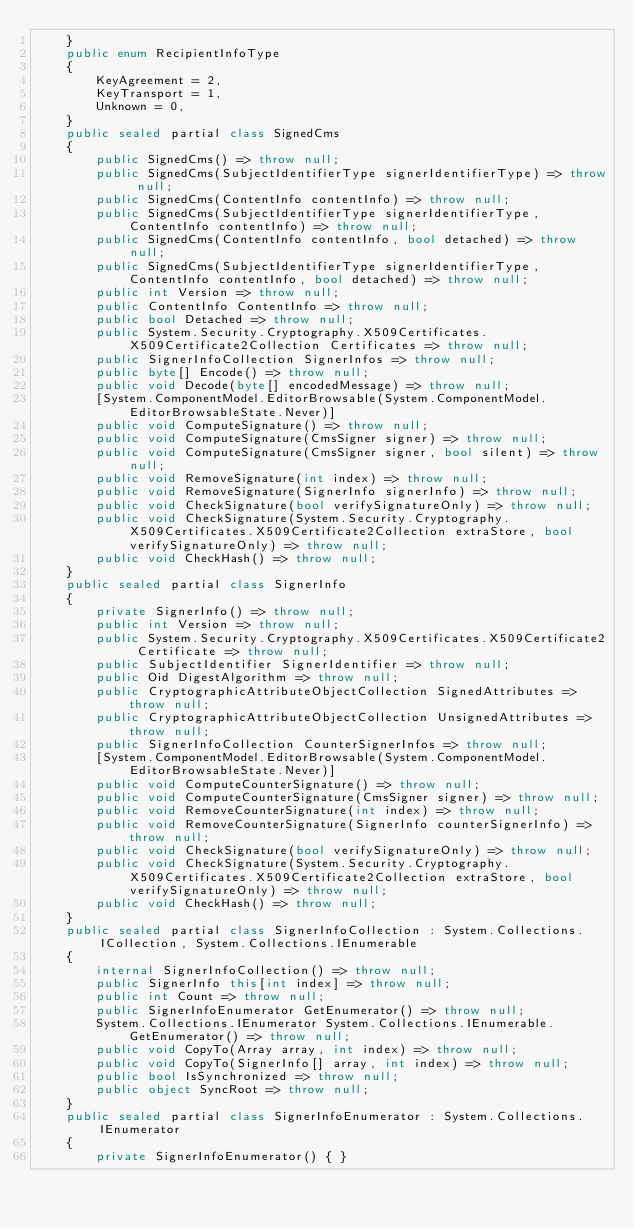Convert code to text. <code><loc_0><loc_0><loc_500><loc_500><_C#_>    }
    public enum RecipientInfoType
    {
        KeyAgreement = 2,
        KeyTransport = 1,
        Unknown = 0,
    }
    public sealed partial class SignedCms
    {
        public SignedCms() => throw null;
        public SignedCms(SubjectIdentifierType signerIdentifierType) => throw null;
        public SignedCms(ContentInfo contentInfo) => throw null;
        public SignedCms(SubjectIdentifierType signerIdentifierType, ContentInfo contentInfo) => throw null;
        public SignedCms(ContentInfo contentInfo, bool detached) => throw null;
        public SignedCms(SubjectIdentifierType signerIdentifierType, ContentInfo contentInfo, bool detached) => throw null;
        public int Version => throw null;
        public ContentInfo ContentInfo => throw null;
        public bool Detached => throw null;
        public System.Security.Cryptography.X509Certificates.X509Certificate2Collection Certificates => throw null;
        public SignerInfoCollection SignerInfos => throw null;
        public byte[] Encode() => throw null;
        public void Decode(byte[] encodedMessage) => throw null;
        [System.ComponentModel.EditorBrowsable(System.ComponentModel.EditorBrowsableState.Never)]
        public void ComputeSignature() => throw null;
        public void ComputeSignature(CmsSigner signer) => throw null;
        public void ComputeSignature(CmsSigner signer, bool silent) => throw null;
        public void RemoveSignature(int index) => throw null;
        public void RemoveSignature(SignerInfo signerInfo) => throw null;
        public void CheckSignature(bool verifySignatureOnly) => throw null;
        public void CheckSignature(System.Security.Cryptography.X509Certificates.X509Certificate2Collection extraStore, bool verifySignatureOnly) => throw null;
        public void CheckHash() => throw null;
    }
    public sealed partial class SignerInfo
    {
        private SignerInfo() => throw null;
        public int Version => throw null;
        public System.Security.Cryptography.X509Certificates.X509Certificate2 Certificate => throw null;
        public SubjectIdentifier SignerIdentifier => throw null;
        public Oid DigestAlgorithm => throw null;
        public CryptographicAttributeObjectCollection SignedAttributes => throw null;
        public CryptographicAttributeObjectCollection UnsignedAttributes => throw null;
        public SignerInfoCollection CounterSignerInfos => throw null;
        [System.ComponentModel.EditorBrowsable(System.ComponentModel.EditorBrowsableState.Never)]
        public void ComputeCounterSignature() => throw null;
        public void ComputeCounterSignature(CmsSigner signer) => throw null;
        public void RemoveCounterSignature(int index) => throw null;
        public void RemoveCounterSignature(SignerInfo counterSignerInfo) => throw null;
        public void CheckSignature(bool verifySignatureOnly) => throw null;
        public void CheckSignature(System.Security.Cryptography.X509Certificates.X509Certificate2Collection extraStore, bool verifySignatureOnly) => throw null;
        public void CheckHash() => throw null;
    }
    public sealed partial class SignerInfoCollection : System.Collections.ICollection, System.Collections.IEnumerable
    {
        internal SignerInfoCollection() => throw null;
        public SignerInfo this[int index] => throw null;
        public int Count => throw null;
        public SignerInfoEnumerator GetEnumerator() => throw null;
        System.Collections.IEnumerator System.Collections.IEnumerable.GetEnumerator() => throw null;
        public void CopyTo(Array array, int index) => throw null;
        public void CopyTo(SignerInfo[] array, int index) => throw null;
        public bool IsSynchronized => throw null;
        public object SyncRoot => throw null;
    }
    public sealed partial class SignerInfoEnumerator : System.Collections.IEnumerator
    {
        private SignerInfoEnumerator() { }</code> 